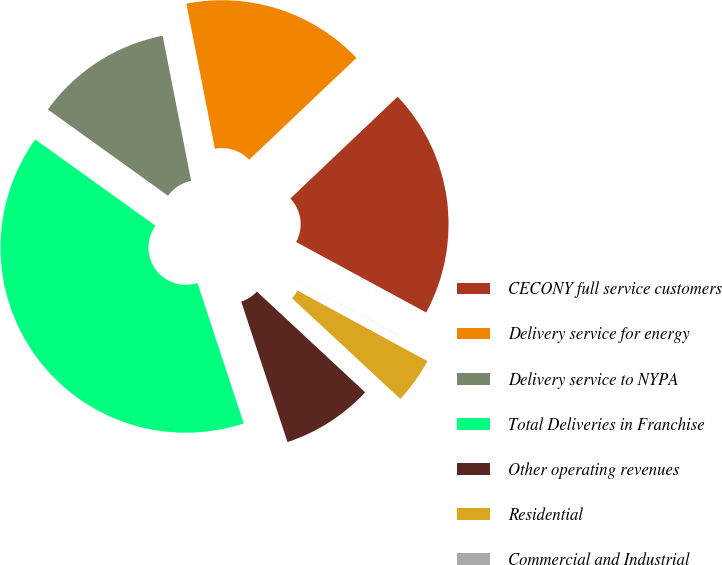Convert chart to OTSL. <chart><loc_0><loc_0><loc_500><loc_500><pie_chart><fcel>CECONY full service customers<fcel>Delivery service for energy<fcel>Delivery service to NYPA<fcel>Total Deliveries in Franchise<fcel>Other operating revenues<fcel>Residential<fcel>Commercial and Industrial<nl><fcel>19.99%<fcel>16.0%<fcel>12.0%<fcel>39.97%<fcel>8.01%<fcel>4.01%<fcel>0.01%<nl></chart> 